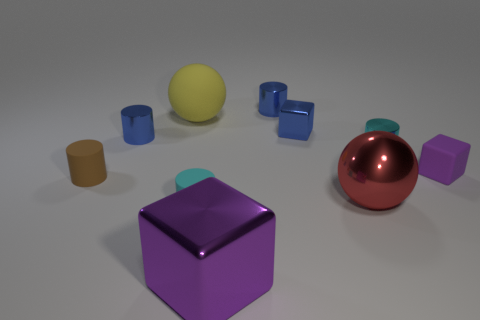There is a metal cylinder on the right side of the red object; is its color the same as the matte cylinder that is on the right side of the yellow thing?
Your answer should be compact. Yes. What number of other objects are there of the same material as the brown cylinder?
Your response must be concise. 3. Are there any tiny rubber cubes?
Provide a short and direct response. Yes. Is the material of the tiny cyan thing that is behind the large red shiny ball the same as the big red ball?
Offer a terse response. Yes. There is another big thing that is the same shape as the big yellow rubber object; what material is it?
Provide a succinct answer. Metal. There is another big block that is the same color as the rubber block; what is it made of?
Your answer should be very brief. Metal. Are there fewer blue metal cylinders than large red balls?
Give a very brief answer. No. Is the color of the cube in front of the brown cylinder the same as the rubber block?
Ensure brevity in your answer.  Yes. What color is the sphere that is the same material as the small purple block?
Your answer should be compact. Yellow. Is the size of the purple metallic thing the same as the cyan metal cylinder?
Make the answer very short. No. 